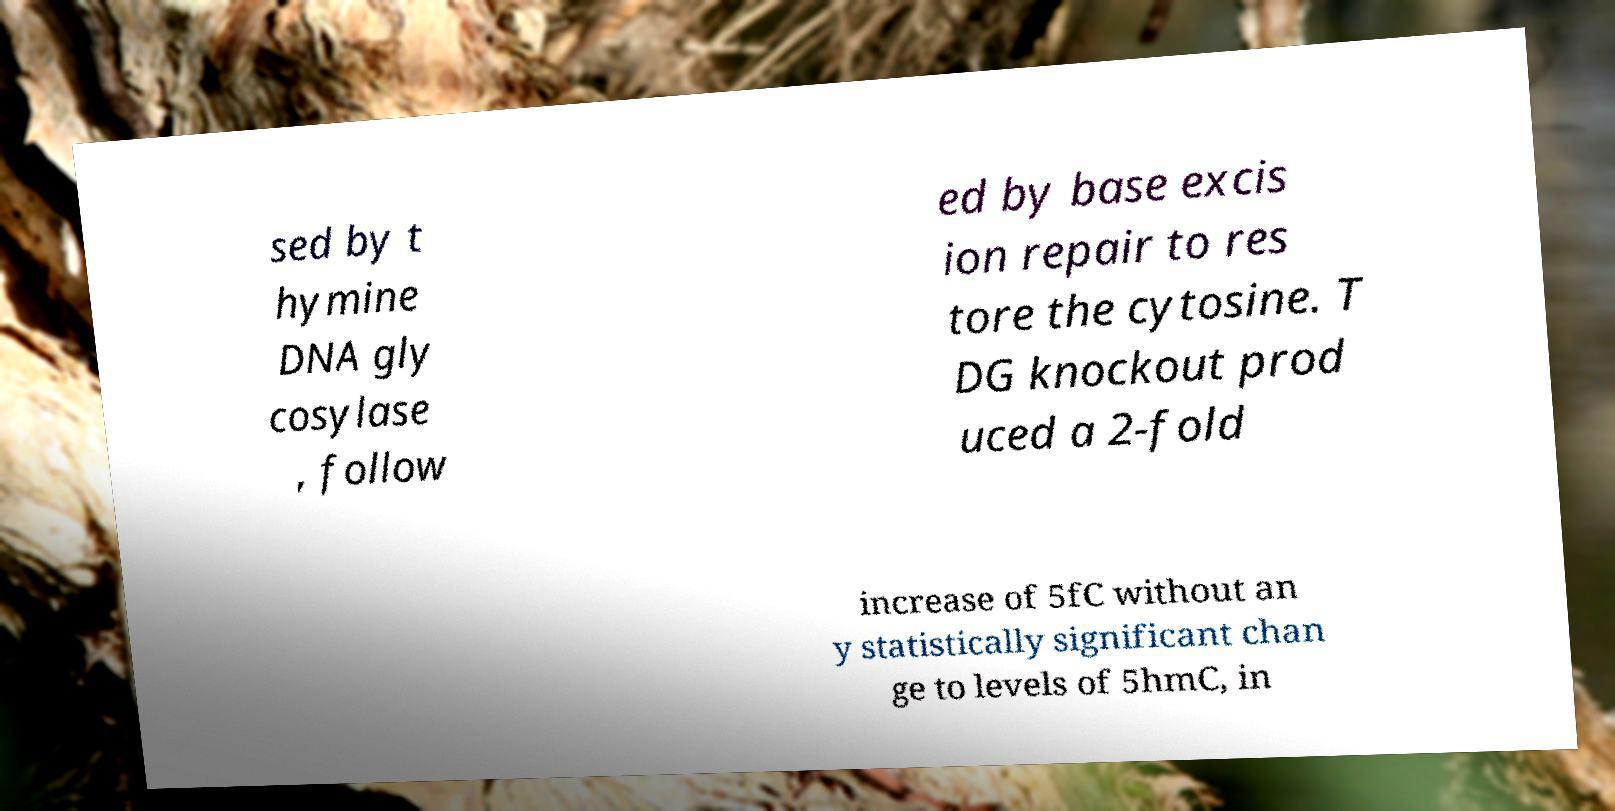Can you accurately transcribe the text from the provided image for me? sed by t hymine DNA gly cosylase , follow ed by base excis ion repair to res tore the cytosine. T DG knockout prod uced a 2-fold increase of 5fC without an y statistically significant chan ge to levels of 5hmC, in 